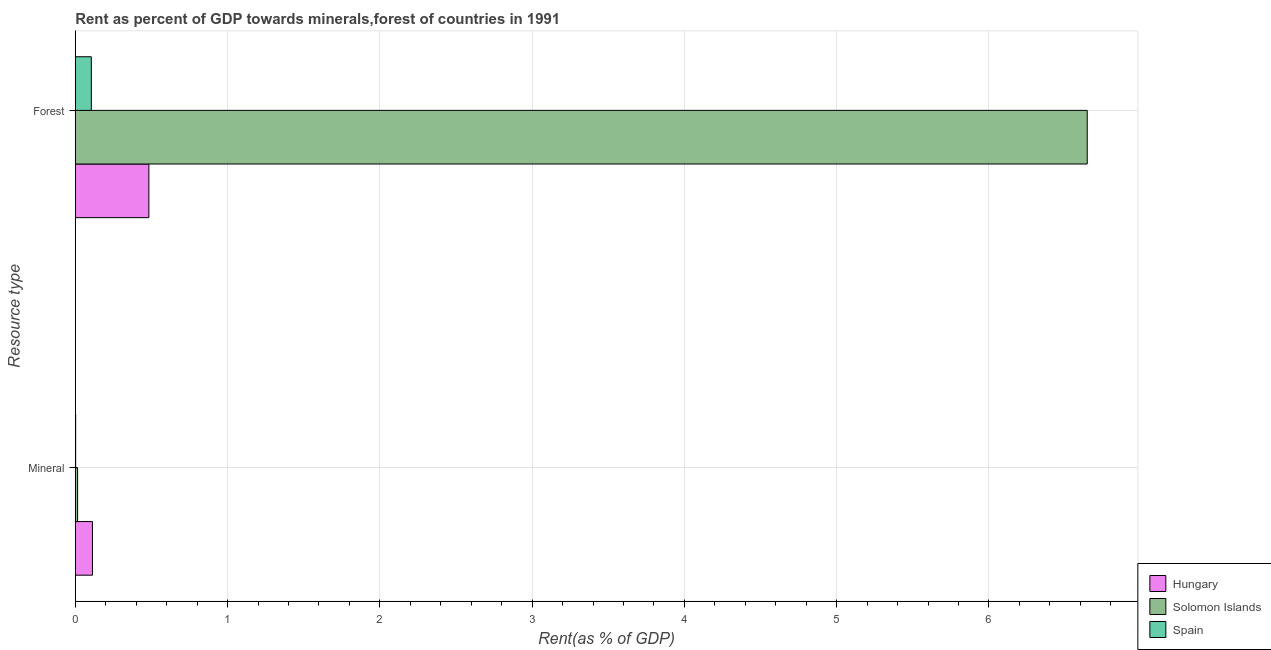How many groups of bars are there?
Offer a very short reply. 2. How many bars are there on the 2nd tick from the top?
Provide a short and direct response. 3. How many bars are there on the 2nd tick from the bottom?
Offer a very short reply. 3. What is the label of the 1st group of bars from the top?
Make the answer very short. Forest. What is the mineral rent in Solomon Islands?
Provide a short and direct response. 0.02. Across all countries, what is the maximum mineral rent?
Keep it short and to the point. 0.11. Across all countries, what is the minimum mineral rent?
Ensure brevity in your answer.  0. In which country was the forest rent maximum?
Give a very brief answer. Solomon Islands. In which country was the forest rent minimum?
Provide a short and direct response. Spain. What is the total forest rent in the graph?
Your answer should be very brief. 7.23. What is the difference between the forest rent in Hungary and that in Solomon Islands?
Your answer should be compact. -6.16. What is the difference between the mineral rent in Solomon Islands and the forest rent in Hungary?
Offer a very short reply. -0.47. What is the average mineral rent per country?
Your answer should be compact. 0.04. What is the difference between the forest rent and mineral rent in Hungary?
Make the answer very short. 0.37. What is the ratio of the forest rent in Solomon Islands to that in Spain?
Offer a very short reply. 63.12. In how many countries, is the mineral rent greater than the average mineral rent taken over all countries?
Provide a succinct answer. 1. What does the 3rd bar from the top in Forest represents?
Your answer should be compact. Hungary. What does the 2nd bar from the bottom in Forest represents?
Ensure brevity in your answer.  Solomon Islands. Are all the bars in the graph horizontal?
Keep it short and to the point. Yes. How many countries are there in the graph?
Offer a very short reply. 3. What is the difference between two consecutive major ticks on the X-axis?
Your response must be concise. 1. Does the graph contain any zero values?
Offer a terse response. No. Does the graph contain grids?
Provide a succinct answer. Yes. Where does the legend appear in the graph?
Give a very brief answer. Bottom right. How many legend labels are there?
Offer a very short reply. 3. What is the title of the graph?
Offer a very short reply. Rent as percent of GDP towards minerals,forest of countries in 1991. Does "St. Lucia" appear as one of the legend labels in the graph?
Offer a very short reply. No. What is the label or title of the X-axis?
Ensure brevity in your answer.  Rent(as % of GDP). What is the label or title of the Y-axis?
Your answer should be very brief. Resource type. What is the Rent(as % of GDP) of Hungary in Mineral?
Keep it short and to the point. 0.11. What is the Rent(as % of GDP) in Solomon Islands in Mineral?
Keep it short and to the point. 0.02. What is the Rent(as % of GDP) of Spain in Mineral?
Offer a very short reply. 0. What is the Rent(as % of GDP) of Hungary in Forest?
Your answer should be very brief. 0.48. What is the Rent(as % of GDP) in Solomon Islands in Forest?
Give a very brief answer. 6.65. What is the Rent(as % of GDP) of Spain in Forest?
Give a very brief answer. 0.11. Across all Resource type, what is the maximum Rent(as % of GDP) in Hungary?
Ensure brevity in your answer.  0.48. Across all Resource type, what is the maximum Rent(as % of GDP) in Solomon Islands?
Your answer should be compact. 6.65. Across all Resource type, what is the maximum Rent(as % of GDP) of Spain?
Ensure brevity in your answer.  0.11. Across all Resource type, what is the minimum Rent(as % of GDP) of Hungary?
Provide a succinct answer. 0.11. Across all Resource type, what is the minimum Rent(as % of GDP) in Solomon Islands?
Your response must be concise. 0.02. Across all Resource type, what is the minimum Rent(as % of GDP) in Spain?
Offer a terse response. 0. What is the total Rent(as % of GDP) in Hungary in the graph?
Make the answer very short. 0.6. What is the total Rent(as % of GDP) of Solomon Islands in the graph?
Your answer should be very brief. 6.66. What is the total Rent(as % of GDP) in Spain in the graph?
Offer a very short reply. 0.11. What is the difference between the Rent(as % of GDP) in Hungary in Mineral and that in Forest?
Ensure brevity in your answer.  -0.37. What is the difference between the Rent(as % of GDP) of Solomon Islands in Mineral and that in Forest?
Offer a very short reply. -6.63. What is the difference between the Rent(as % of GDP) in Spain in Mineral and that in Forest?
Ensure brevity in your answer.  -0.1. What is the difference between the Rent(as % of GDP) of Hungary in Mineral and the Rent(as % of GDP) of Solomon Islands in Forest?
Your answer should be very brief. -6.53. What is the difference between the Rent(as % of GDP) in Hungary in Mineral and the Rent(as % of GDP) in Spain in Forest?
Offer a terse response. 0.01. What is the difference between the Rent(as % of GDP) of Solomon Islands in Mineral and the Rent(as % of GDP) of Spain in Forest?
Give a very brief answer. -0.09. What is the average Rent(as % of GDP) in Hungary per Resource type?
Offer a very short reply. 0.3. What is the average Rent(as % of GDP) in Solomon Islands per Resource type?
Give a very brief answer. 3.33. What is the average Rent(as % of GDP) in Spain per Resource type?
Give a very brief answer. 0.05. What is the difference between the Rent(as % of GDP) of Hungary and Rent(as % of GDP) of Solomon Islands in Mineral?
Ensure brevity in your answer.  0.1. What is the difference between the Rent(as % of GDP) of Hungary and Rent(as % of GDP) of Spain in Mineral?
Provide a succinct answer. 0.11. What is the difference between the Rent(as % of GDP) of Solomon Islands and Rent(as % of GDP) of Spain in Mineral?
Your response must be concise. 0.01. What is the difference between the Rent(as % of GDP) of Hungary and Rent(as % of GDP) of Solomon Islands in Forest?
Your response must be concise. -6.16. What is the difference between the Rent(as % of GDP) in Hungary and Rent(as % of GDP) in Spain in Forest?
Ensure brevity in your answer.  0.38. What is the difference between the Rent(as % of GDP) of Solomon Islands and Rent(as % of GDP) of Spain in Forest?
Your answer should be compact. 6.54. What is the ratio of the Rent(as % of GDP) in Hungary in Mineral to that in Forest?
Your response must be concise. 0.23. What is the ratio of the Rent(as % of GDP) in Solomon Islands in Mineral to that in Forest?
Keep it short and to the point. 0. What is the ratio of the Rent(as % of GDP) in Spain in Mineral to that in Forest?
Make the answer very short. 0.02. What is the difference between the highest and the second highest Rent(as % of GDP) in Hungary?
Your response must be concise. 0.37. What is the difference between the highest and the second highest Rent(as % of GDP) in Solomon Islands?
Your answer should be very brief. 6.63. What is the difference between the highest and the second highest Rent(as % of GDP) in Spain?
Your answer should be compact. 0.1. What is the difference between the highest and the lowest Rent(as % of GDP) of Hungary?
Ensure brevity in your answer.  0.37. What is the difference between the highest and the lowest Rent(as % of GDP) in Solomon Islands?
Your answer should be very brief. 6.63. What is the difference between the highest and the lowest Rent(as % of GDP) of Spain?
Your answer should be compact. 0.1. 